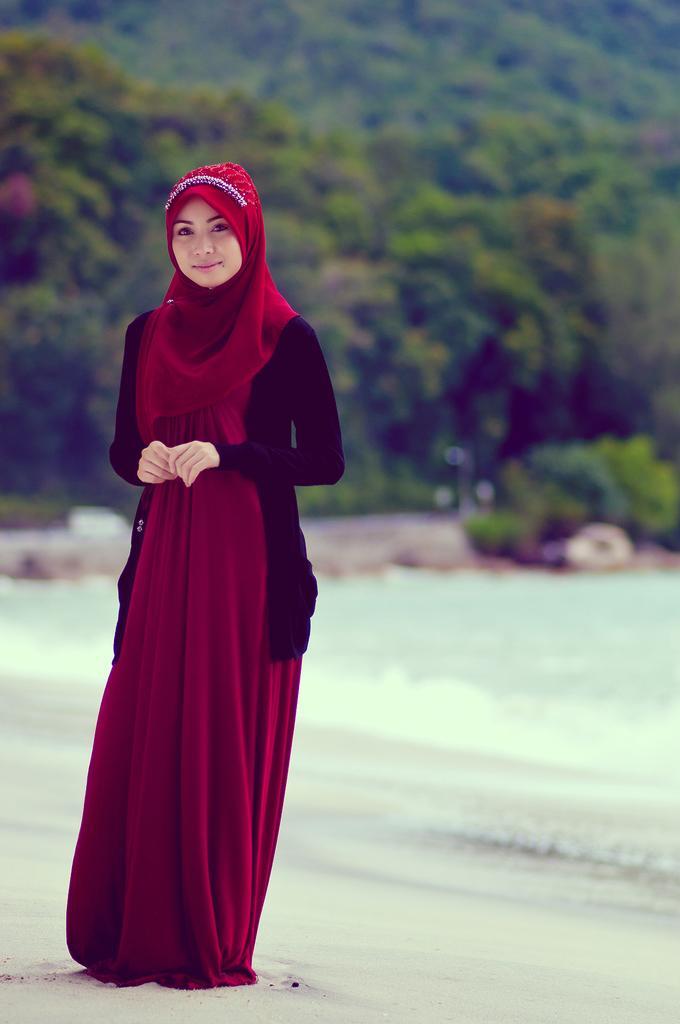Please provide a concise description of this image. In this picture there is a girl on the left side of the image and there is greenery in the background area of the image. 